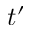Convert formula to latex. <formula><loc_0><loc_0><loc_500><loc_500>t ^ { \prime }</formula> 